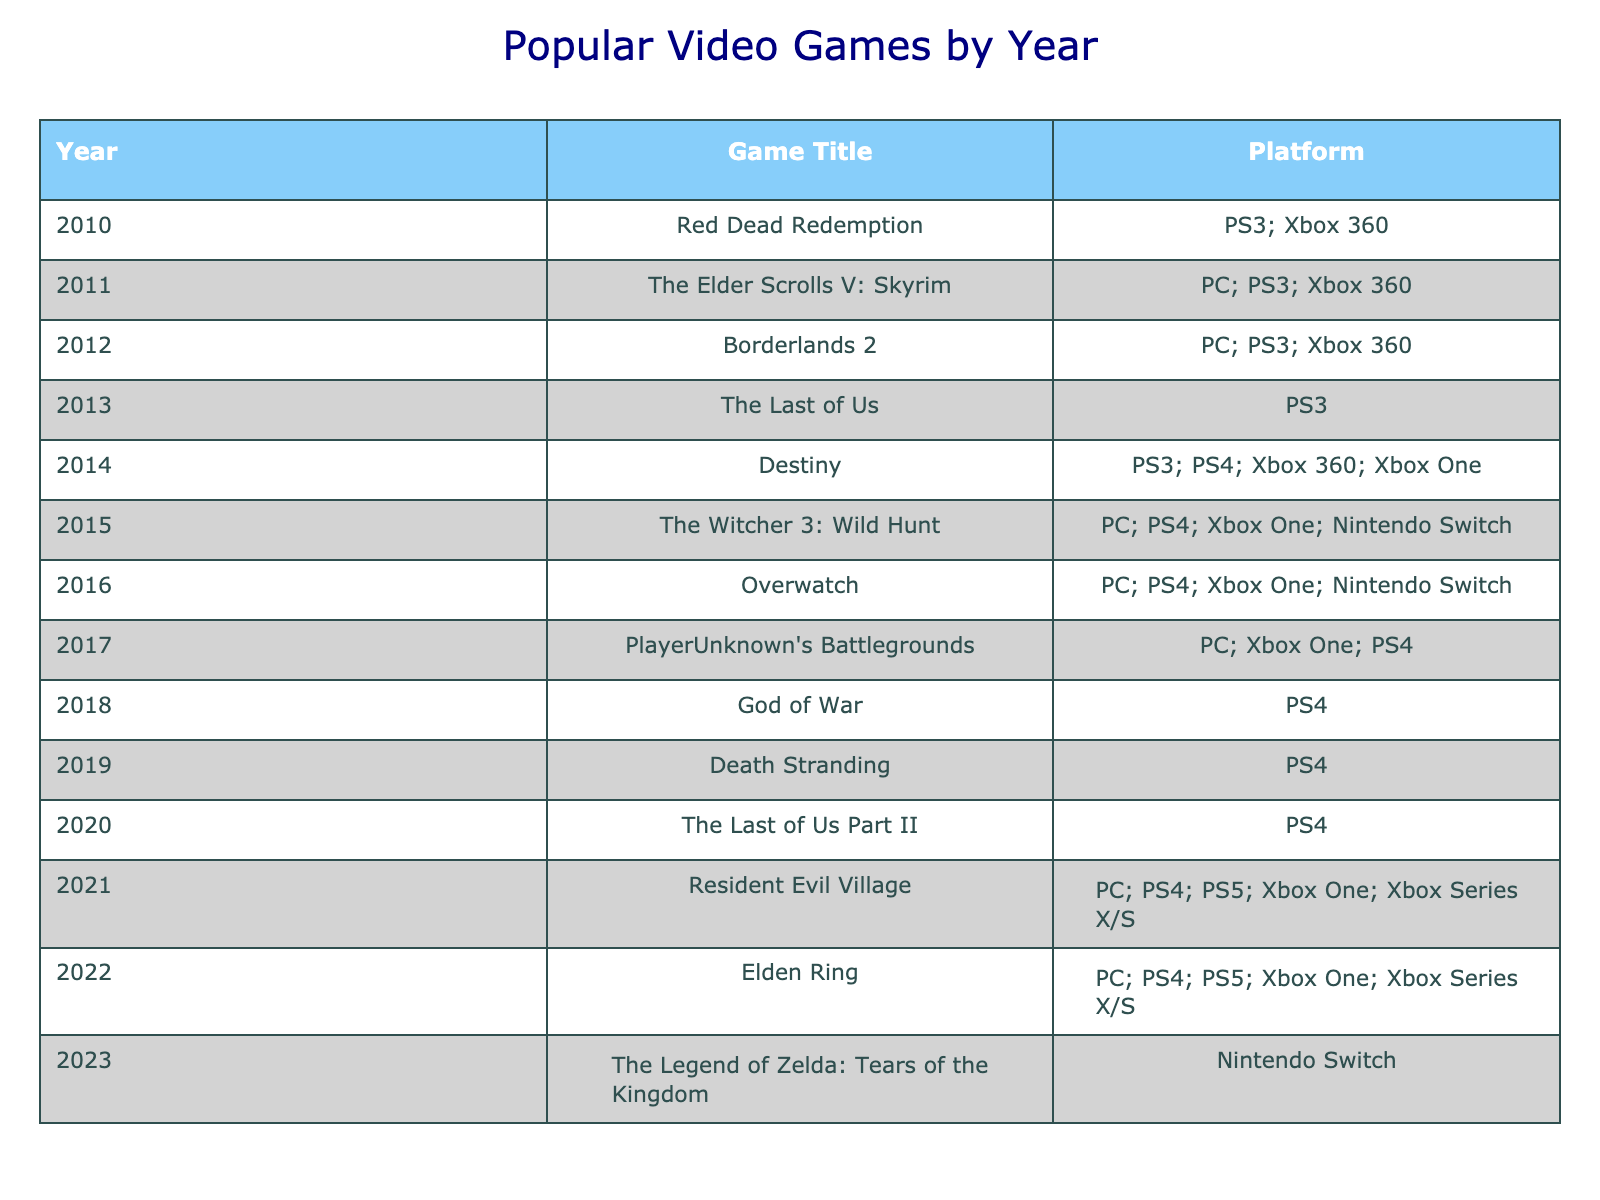What video game was released in 2015? Looking at the table, the row for the year 2015 shows "The Witcher 3: Wild Hunt."
Answer: The Witcher 3: Wild Hunt Which platform did "The Last of Us" release on? The row for "The Last of Us" in 2013 indicates that it was released on the PS3.
Answer: PS3 How many games were released in 2021? Reviewing the table, the year 2021 lists one game: "Resident Evil Village." Therefore, the count of games is 1.
Answer: 1 Is "Elden Ring" available on PS5? The table shows that "Elden Ring" in 2022 is listed under PS5 as one of the platforms.
Answer: Yes In which year did the most games appear (by count)? Counting the unique titles from each year, 2014 has the most entries (4 games: "Destiny"). This is confirmed by going through all years and tallying the number of games.
Answer: 2014 Which platform had the highest number of unique game titles released from 2010 to 2023? By analyzing the platform column, PC appears frequently, and if you tally the unique game titles across its appearances, PC has the most. It appears 7 times compared to other platforms.
Answer: PC What is the difference in years between the release of "The Elder Scrolls V: Skyrim" and "God of War"? "The Elder Scrolls V: Skyrim" was released in 2011 and "God of War" in 2018. The difference in years is 2018 - 2011 = 7 years.
Answer: 7 years How many games were released on the Xbox One? The table shows games released on Xbox One (Destiny, The Witcher 3: Wild Hunt, Overwatch, PUBG, Resident Evil Village, Elden Ring), totaling 6 unique titles.
Answer: 6 Were there any games released on both PS4 and Xbox One? The table shows several games that appear on both platforms, namely "Destiny," "The Witcher 3: Wild Hunt," "Resident Evil Village," and "Elden Ring." Therefore, the answer is yes.
Answer: Yes 